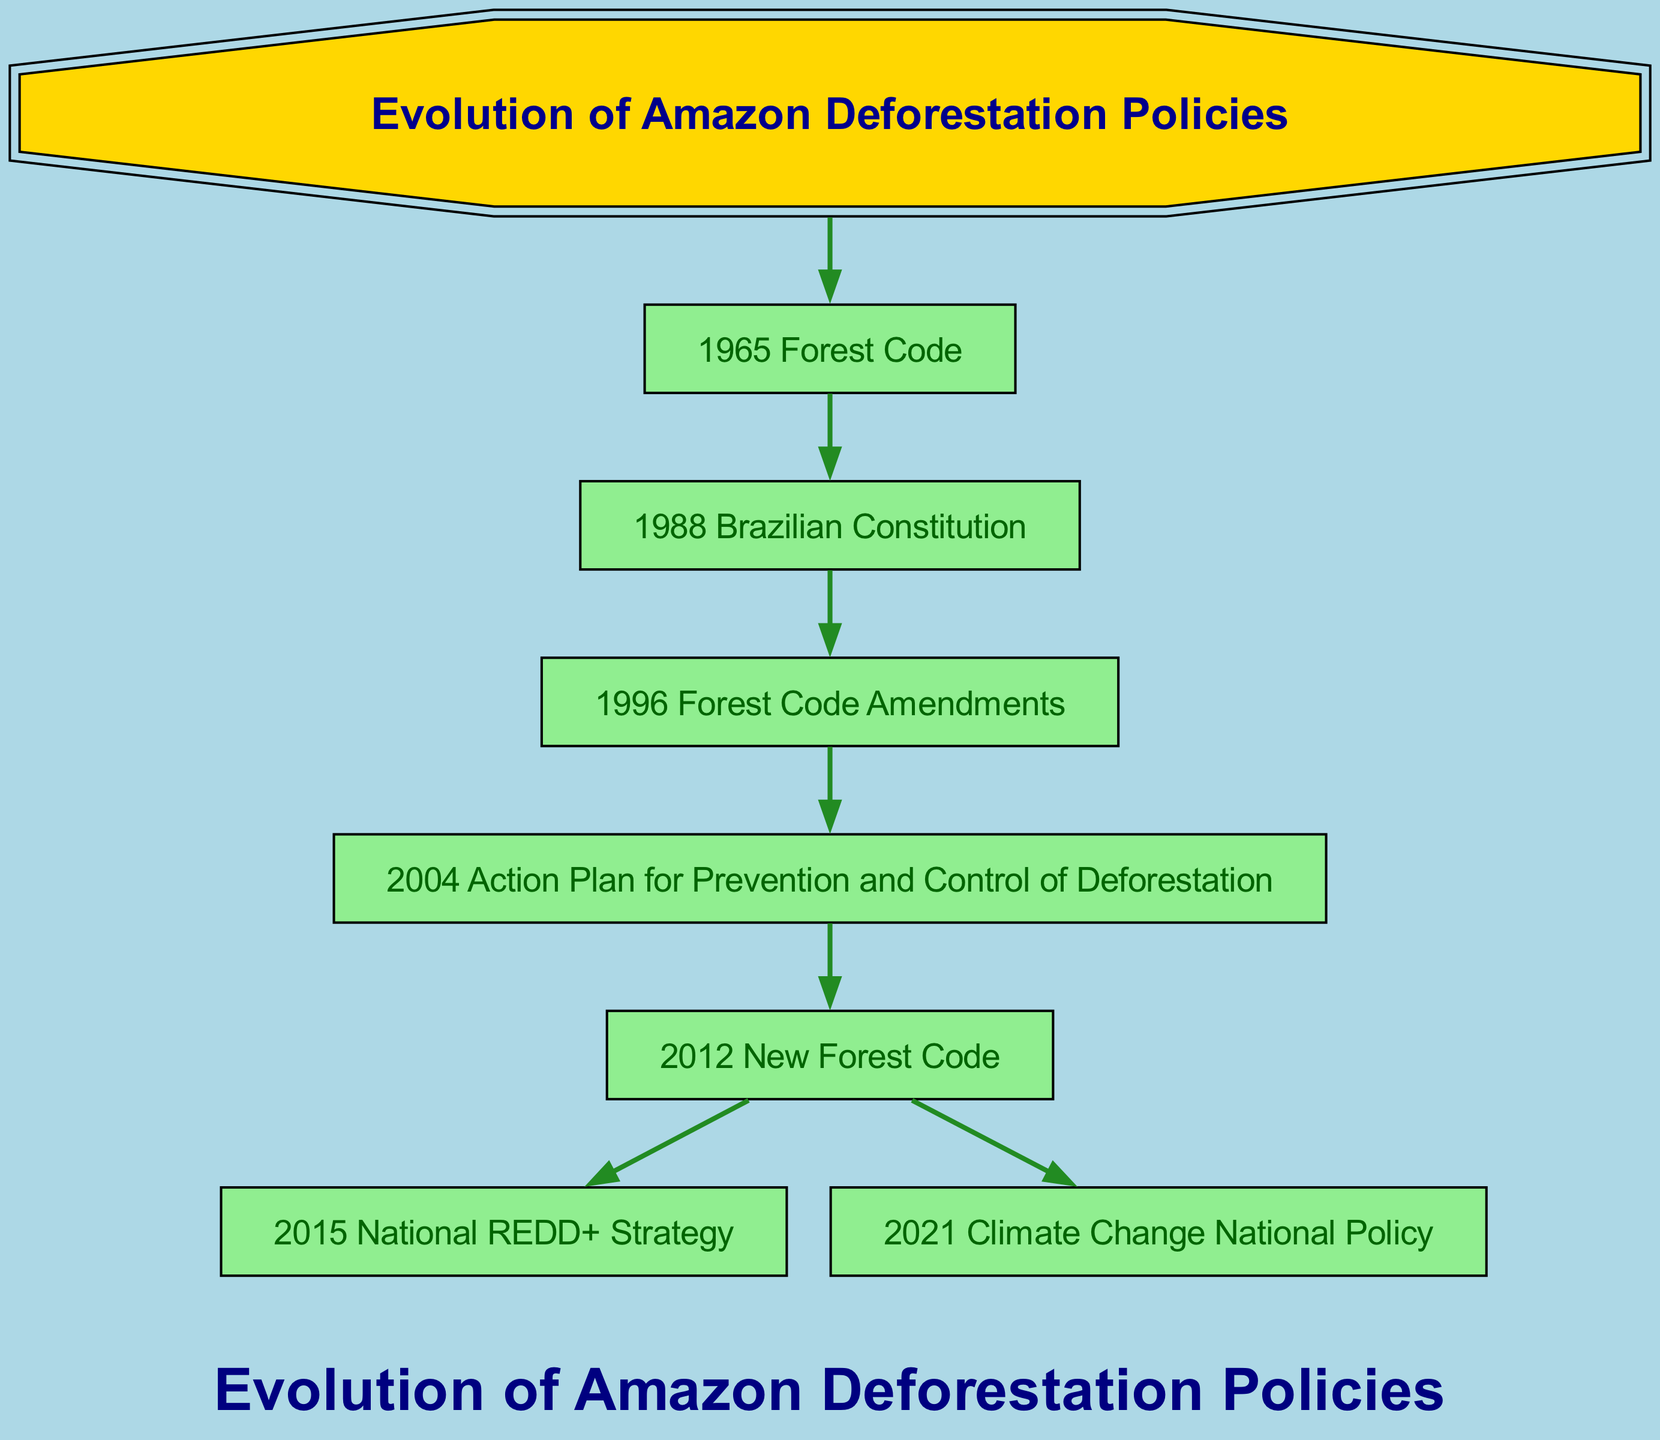What is the root of the family tree? The root of the family tree is labeled as "Evolution of Amazon Deforestation Policies". This is the starting point from which all other nodes branch out, representing the overall theme of the diagram.
Answer: Evolution of Amazon Deforestation Policies How many children does the "1965 Forest Code" node have? The "1965 Forest Code" node has one child, which is the "1988 Brazilian Constitution". By counting the branches under "1965 Forest Code", we see that there is only one additional node leading from it.
Answer: 1 What legislative document follows the "1988 Brazilian Constitution"? After the "1988 Brazilian Constitution", the next legislative document is "1996 Forest Code Amendments". This can be determined by following the path from the "1988 Brazilian Constitution" node to its direct child.
Answer: 1996 Forest Code Amendments Which action plan was initiated in 2004? The action plan that was initiated in 2004 is labeled as "2004 Action Plan for Prevention and Control of Deforestation". This is found as a child node under the "1996 Forest Code Amendments" node, which signifies its chronological placement.
Answer: 2004 Action Plan for Prevention and Control of Deforestation What are the two children of the "2012 New Forest Code"? The two children of the "2012 New Forest Code" are "2015 National REDD+ Strategy" and "2021 Climate Change National Policy". By identifying the nodes that branch out from "2012 New Forest Code", we see these two entities directly connected.
Answer: 2015 National REDD+ Strategy and 2021 Climate Change National Policy Which legislative document connects "1996 Forest Code Amendments" and the "2012 New Forest Code"? The document that serves as the connection between "1996 Forest Code Amendments" and the "2012 New Forest Code" is the "2004 Action Plan for Prevention and Control of Deforestation". It acts as an intermediary node, linking these two related policies in the timeline.
Answer: 2004 Action Plan for Prevention and Control of Deforestation What is the last document mentioned in the family tree? The last document mentioned in the family tree is the "2021 Climate Change National Policy". This is identified as the final child node in the sequence of branches, positioned at the end of the flow.
Answer: 2021 Climate Change National Policy How many total legislative documents are present in the tree? There are a total of six legislative documents present in the tree, including the root. This is calculated by counting each individual node, including the main policies and actions represented.
Answer: 6 Which node has the most children? The node with the most children is the "2012 New Forest Code" node, which has two direct children: "2015 National REDD+ Strategy" and "2021 Climate Change National Policy". This can be verified by examining the branching of the nodes connected to it.
Answer: 2012 New Forest Code 